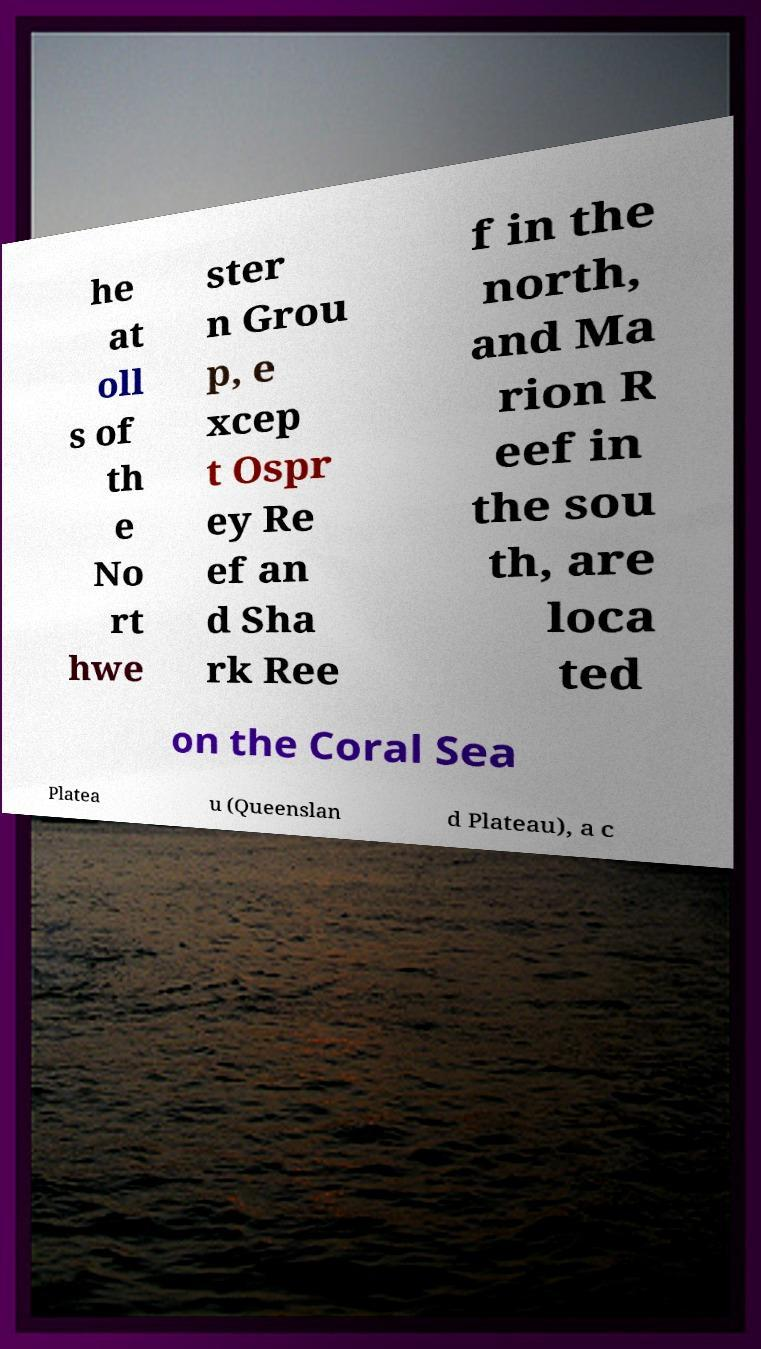Could you assist in decoding the text presented in this image and type it out clearly? he at oll s of th e No rt hwe ster n Grou p, e xcep t Ospr ey Re ef an d Sha rk Ree f in the north, and Ma rion R eef in the sou th, are loca ted on the Coral Sea Platea u (Queenslan d Plateau), a c 